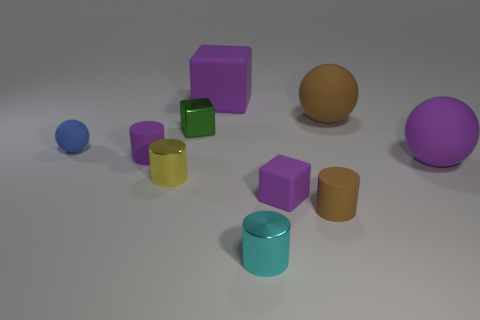Subtract all red cylinders. How many purple blocks are left? 2 Subtract all purple cubes. How many cubes are left? 1 Subtract 1 spheres. How many spheres are left? 2 Subtract all purple cylinders. How many cylinders are left? 3 Subtract all green cylinders. Subtract all red blocks. How many cylinders are left? 4 Subtract all blocks. How many objects are left? 7 Subtract 0 cyan cubes. How many objects are left? 10 Subtract all balls. Subtract all red metallic cubes. How many objects are left? 7 Add 4 green cubes. How many green cubes are left? 5 Add 2 tiny cyan blocks. How many tiny cyan blocks exist? 2 